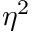Convert formula to latex. <formula><loc_0><loc_0><loc_500><loc_500>\eta ^ { 2 }</formula> 